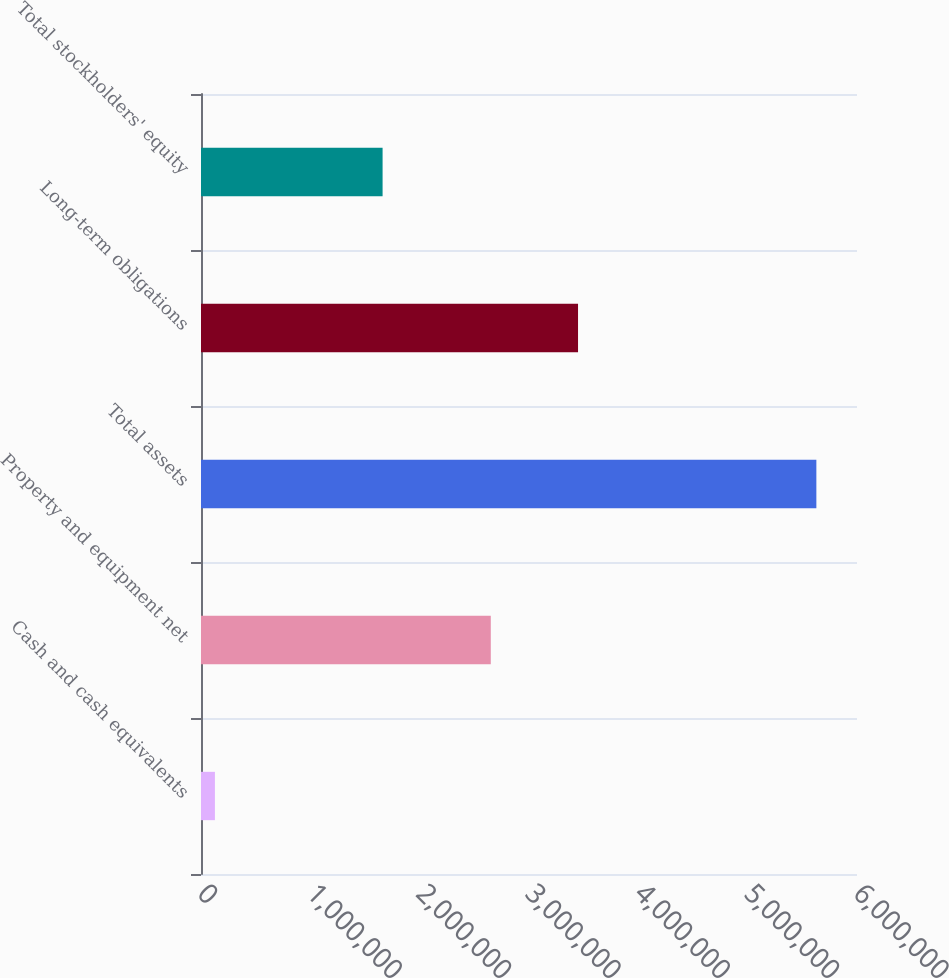Convert chart. <chart><loc_0><loc_0><loc_500><loc_500><bar_chart><fcel>Cash and cash equivalents<fcel>Property and equipment net<fcel>Total assets<fcel>Long-term obligations<fcel>Total stockholders' equity<nl><fcel>127292<fcel>2.65049e+06<fcel>5.62832e+06<fcel>3.44851e+06<fcel>1.66086e+06<nl></chart> 